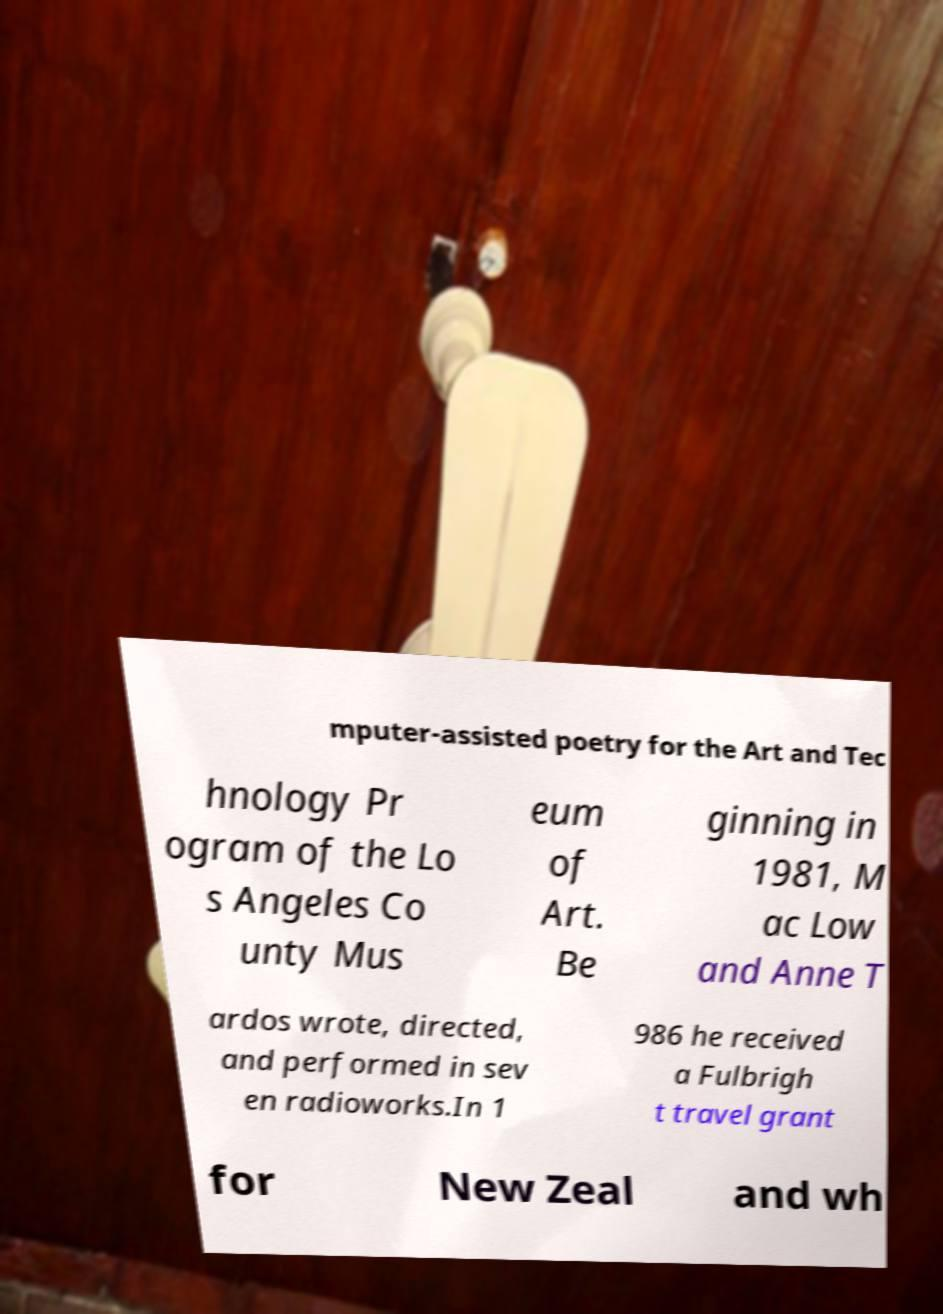Can you read and provide the text displayed in the image?This photo seems to have some interesting text. Can you extract and type it out for me? mputer-assisted poetry for the Art and Tec hnology Pr ogram of the Lo s Angeles Co unty Mus eum of Art. Be ginning in 1981, M ac Low and Anne T ardos wrote, directed, and performed in sev en radioworks.In 1 986 he received a Fulbrigh t travel grant for New Zeal and wh 